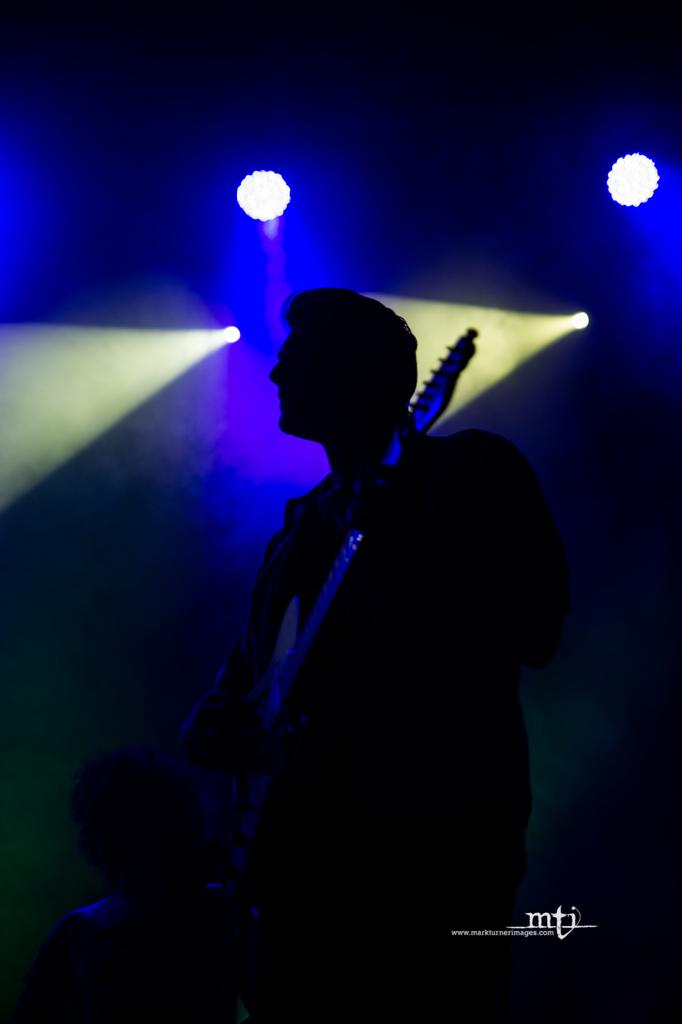What is the person in the image holding? The person is holding a guitar in the image. How would you describe the overall lighting in the image? The background of the image is dark, but there are lights visible. Can you describe the position of the person at the bottom of the image? There is a person at the bottom of the image, but their specific position or action cannot be determined from the provided facts. Is there any additional information or branding present in the image? Yes, there is a watermark in the image. What type of paste is being used by the person in the image? There is no indication of any paste being used in the image; the person is holding a guitar. 